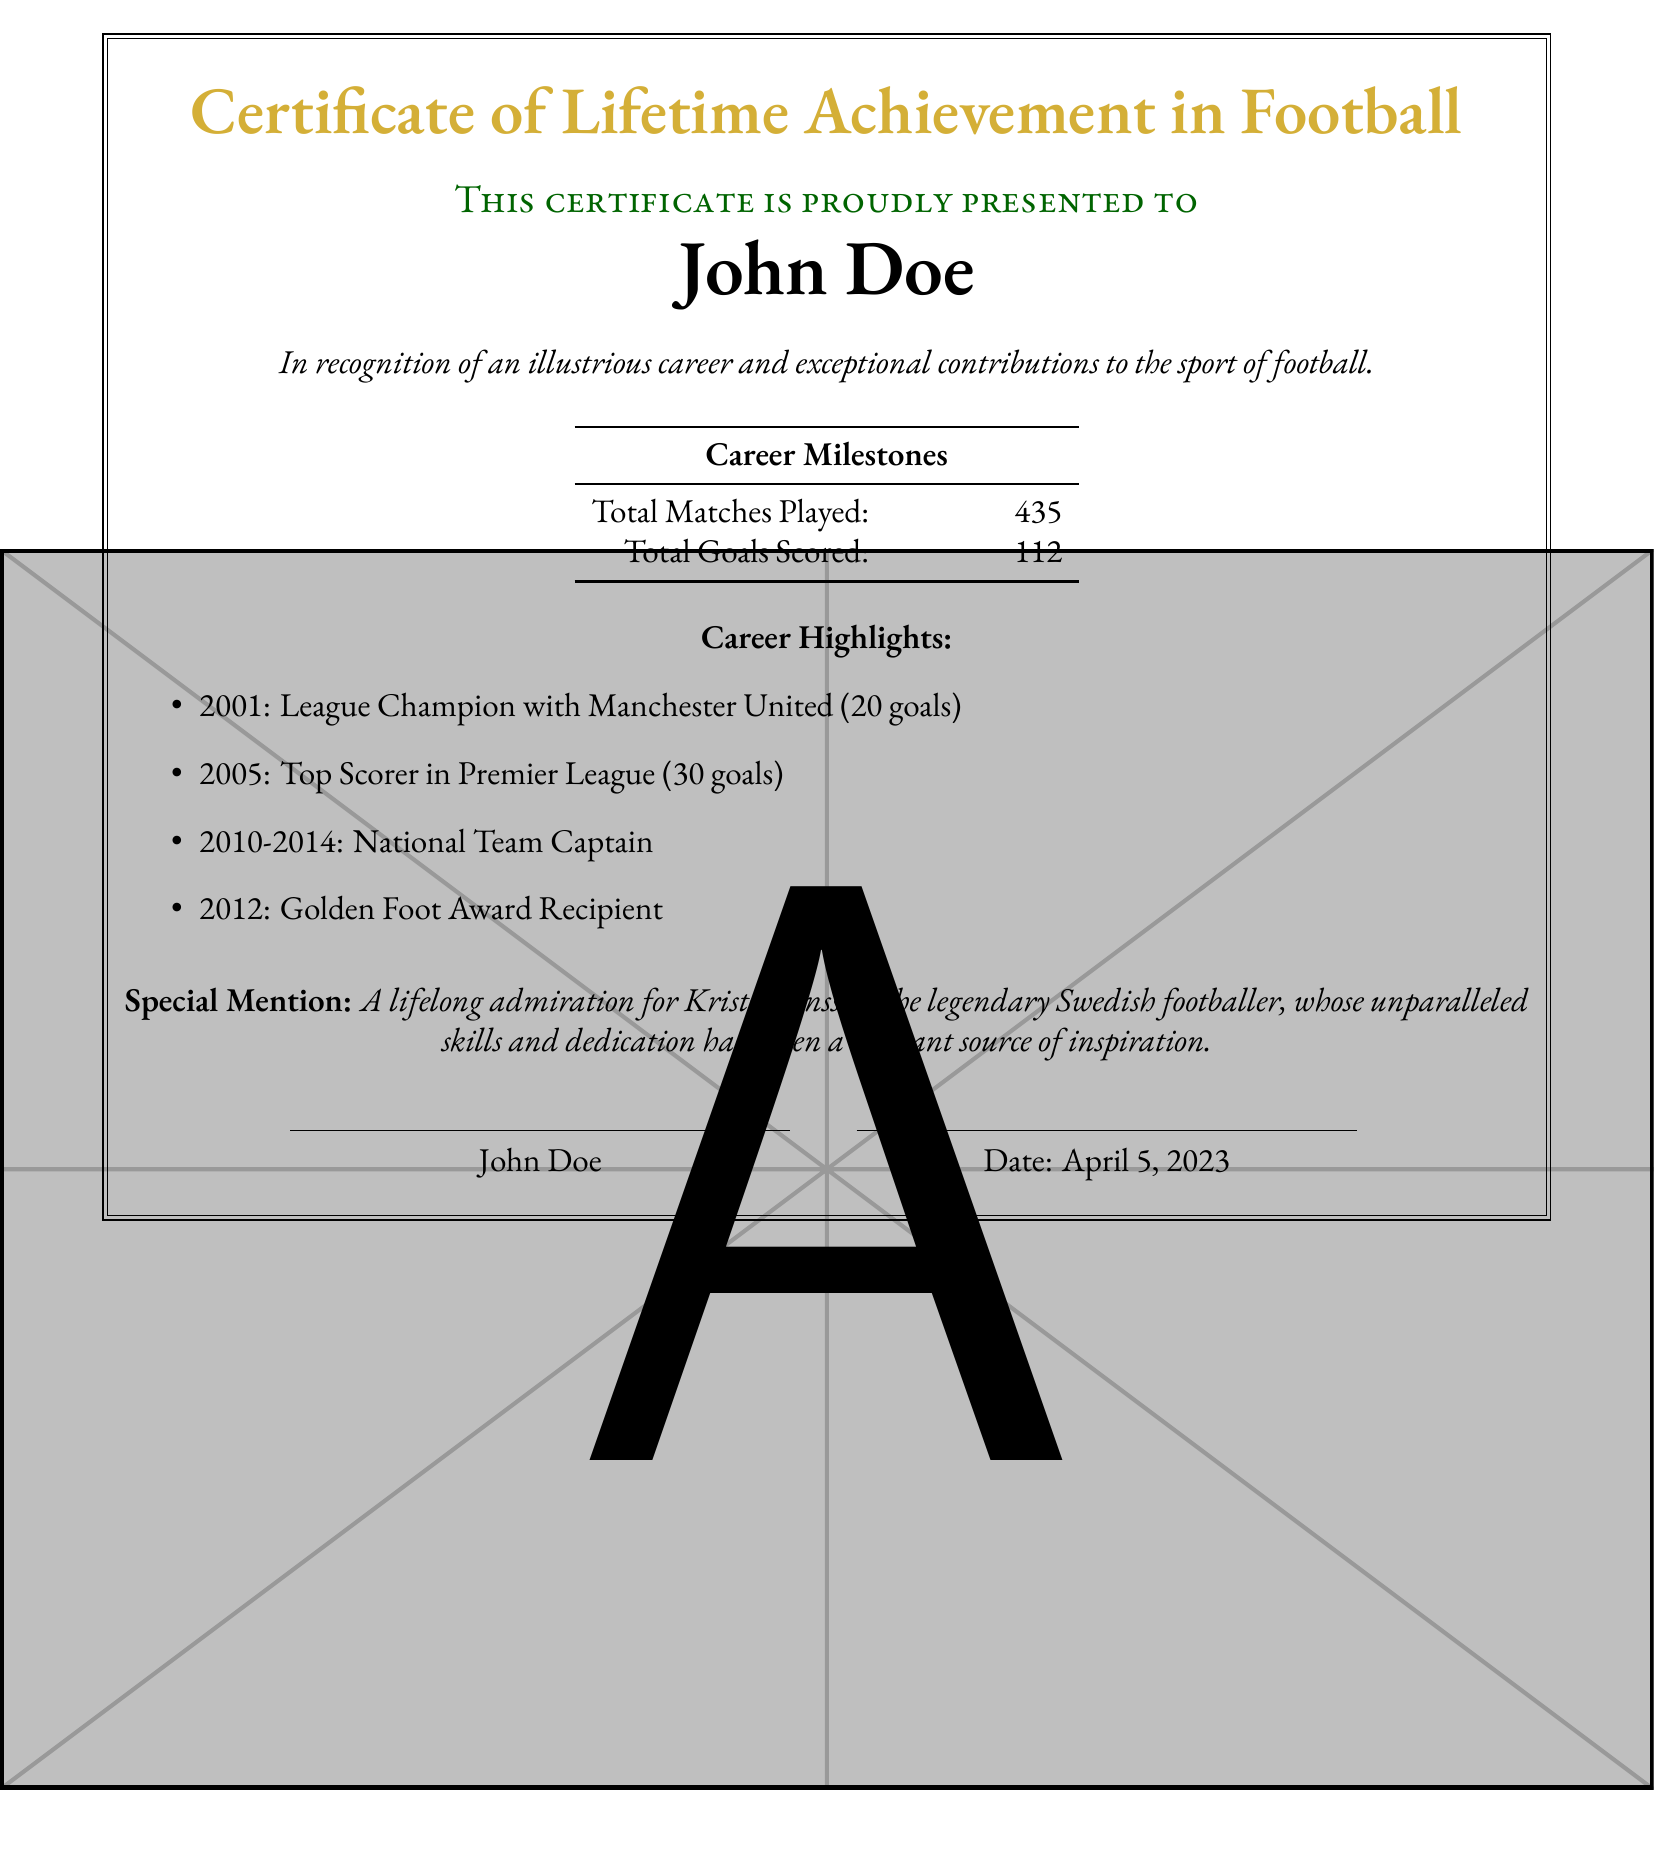What is the title of the certificate? The title of the certificate is prominently displayed at the top of the document, stating the recognition being given.
Answer: Certificate of Lifetime Achievement in Football Who is the certificate awarded to? The recipient's name is clearly stated in a larger font, indicating who is being recognized.
Answer: John Doe How many total matches were played during the career? The document includes a section that summarizes career milestones, one of which is total matches played.
Answer: 435 What year did John Doe become a League Champion with Manchester United? The document lists this achievement under career highlights, indicating the year it occurred.
Answer: 2001 What is the total number of goals scored in John Doe's career? A specific milestone in the document details the total goals scored throughout his professional career.
Answer: 112 Which prestigious award did John Doe receive in 2012? The document mentions this award as a notable achievement in the list of career highlights.
Answer: Golden Foot Award What significant role did John Doe hold from 2010 to 2014? This information is highlighted in the career highlights section, indicating a key position held during that time.
Answer: National Team Captain Who is specifically mentioned with admiration in the certificate? A special mention section expresses admiration for a notable footballer, making this request clear.
Answer: Kristin Jonsson 